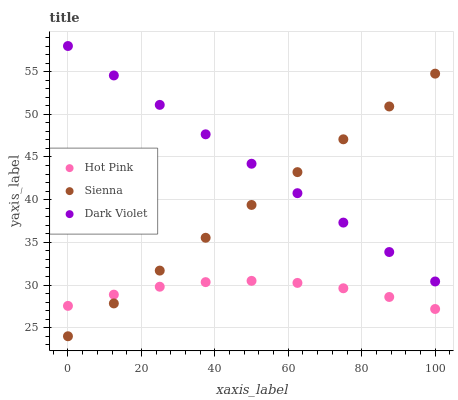Does Hot Pink have the minimum area under the curve?
Answer yes or no. Yes. Does Dark Violet have the maximum area under the curve?
Answer yes or no. Yes. Does Dark Violet have the minimum area under the curve?
Answer yes or no. No. Does Hot Pink have the maximum area under the curve?
Answer yes or no. No. Is Dark Violet the smoothest?
Answer yes or no. Yes. Is Hot Pink the roughest?
Answer yes or no. Yes. Is Hot Pink the smoothest?
Answer yes or no. No. Is Dark Violet the roughest?
Answer yes or no. No. Does Sienna have the lowest value?
Answer yes or no. Yes. Does Hot Pink have the lowest value?
Answer yes or no. No. Does Dark Violet have the highest value?
Answer yes or no. Yes. Does Hot Pink have the highest value?
Answer yes or no. No. Is Hot Pink less than Dark Violet?
Answer yes or no. Yes. Is Dark Violet greater than Hot Pink?
Answer yes or no. Yes. Does Sienna intersect Dark Violet?
Answer yes or no. Yes. Is Sienna less than Dark Violet?
Answer yes or no. No. Is Sienna greater than Dark Violet?
Answer yes or no. No. Does Hot Pink intersect Dark Violet?
Answer yes or no. No. 